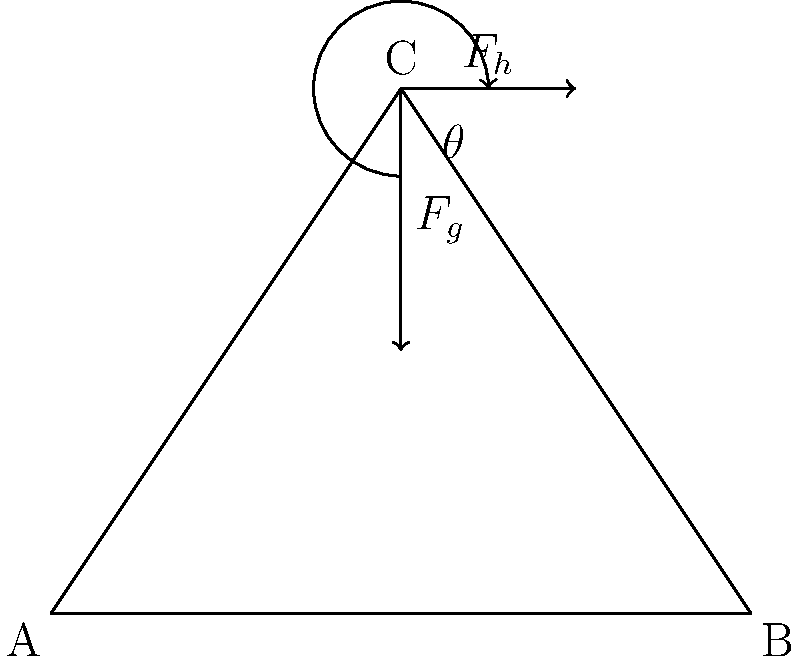In a theatrical production, an actor lifts a heavy prop weighing 200 N at an angle of 30° from the horizontal. If the actor exerts a horizontal force ($F_h$) of 150 N to move the prop, calculate the vertical force ($F_v$) required to lift and hold the prop steady. Use the free-body diagram provided and assume the system is in equilibrium. To solve this problem, we'll use the principles of static equilibrium and vector decomposition. Let's break it down step-by-step:

1) First, we need to identify the forces acting on the prop:
   - Weight of the prop ($F_g$) = 200 N (acting downward)
   - Horizontal force ($F_h$) = 150 N (given)
   - Vertical force ($F_v$) (unknown, acting upward)

2) For equilibrium, the sum of forces in both x and y directions must be zero:

   $$\sum F_x = 0$$ and $$\sum F_y = 0$$

3) In the x-direction:
   $$F_h - F \cos(30°) = 0$$
   Where $F$ is the total force exerted by the actor.

4) In the y-direction:
   $$F_v - F \sin(30°) - F_g = 0$$

5) From step 3, we can calculate $F$:
   $$F = \frac{F_h}{\cos(30°)} = \frac{150}{\cos(30°)} \approx 173.2 \text{ N}$$

6) Now we can substitute this into the y-direction equation:
   $$F_v - 173.2 \sin(30°) - 200 = 0$$

7) Solving for $F_v$:
   $$F_v = 173.2 \sin(30°) + 200$$
   $$F_v = 173.2 \cdot 0.5 + 200 \approx 286.6 \text{ N}$$

Therefore, the vertical force required to lift and hold the prop steady is approximately 286.6 N.
Answer: 286.6 N 